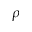<formula> <loc_0><loc_0><loc_500><loc_500>\rho</formula> 